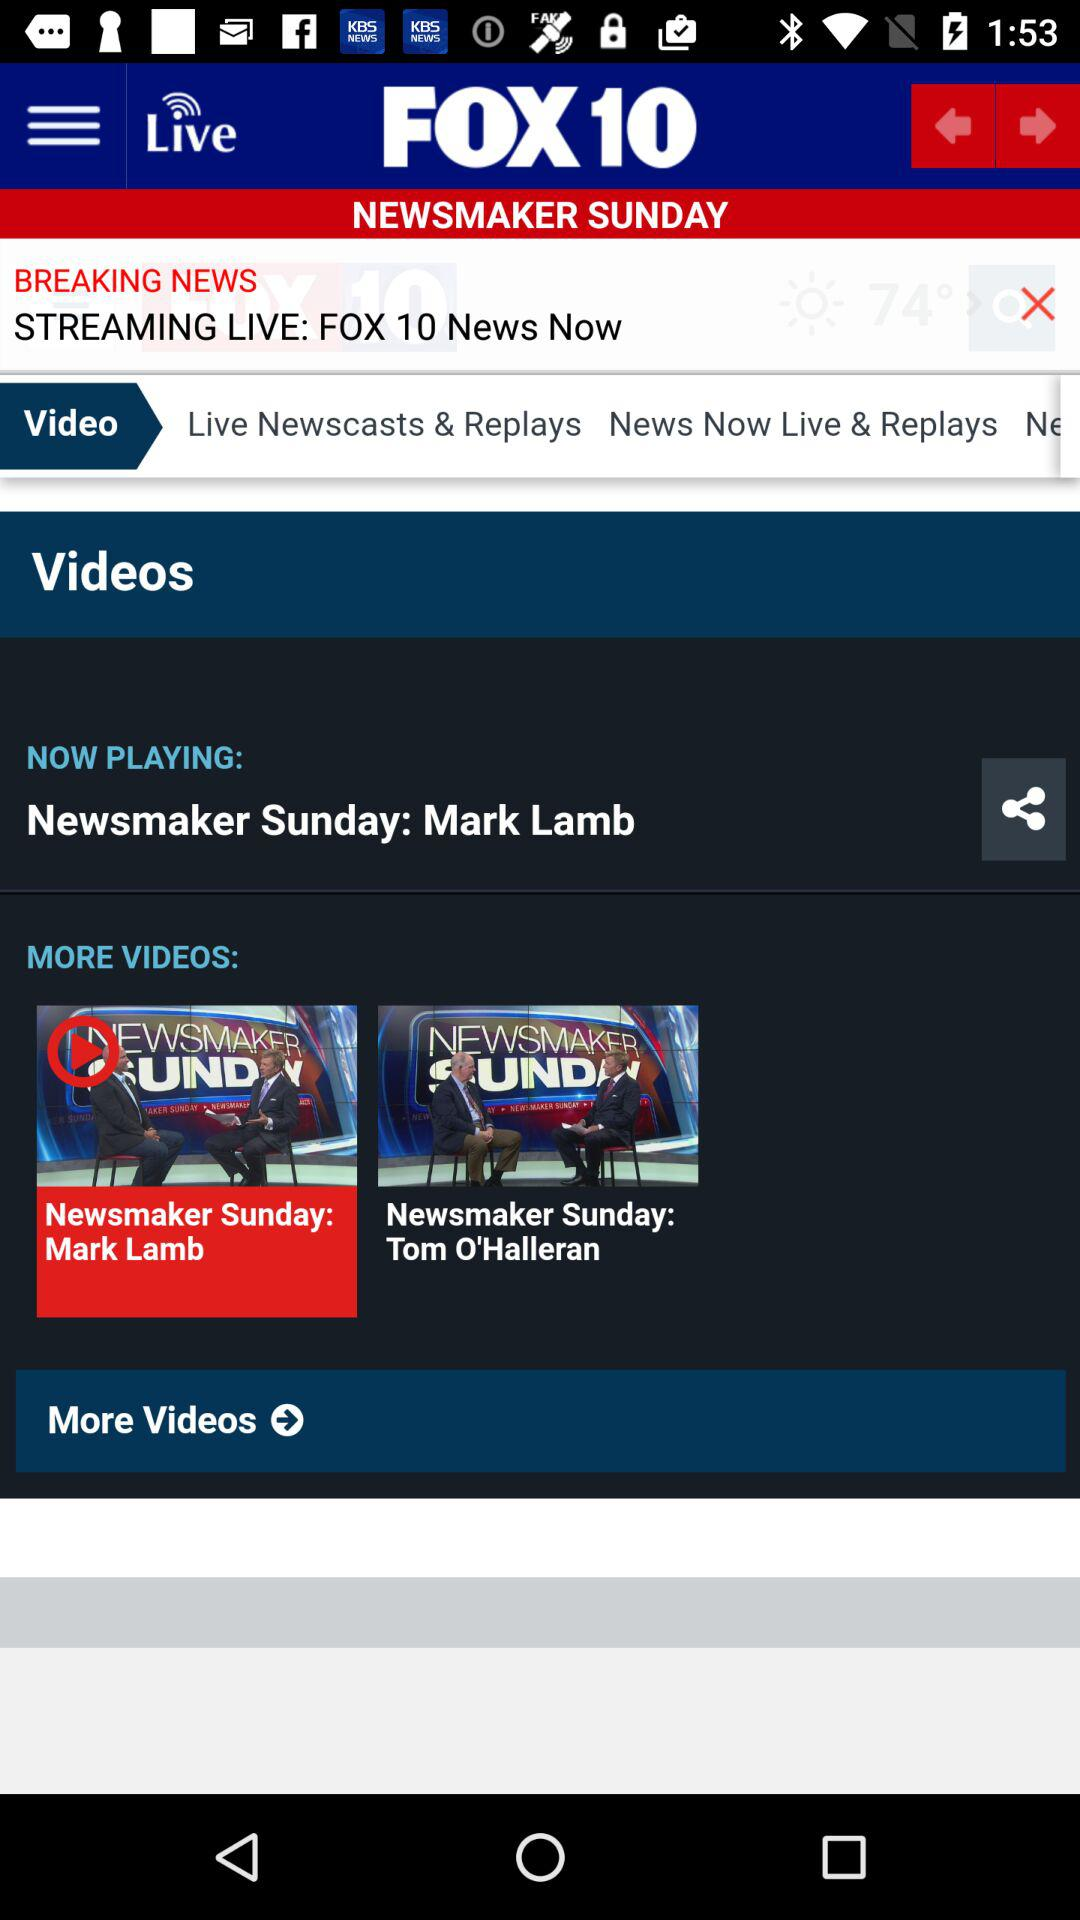What is the name of the application? The name of the application is "FOX 10". 